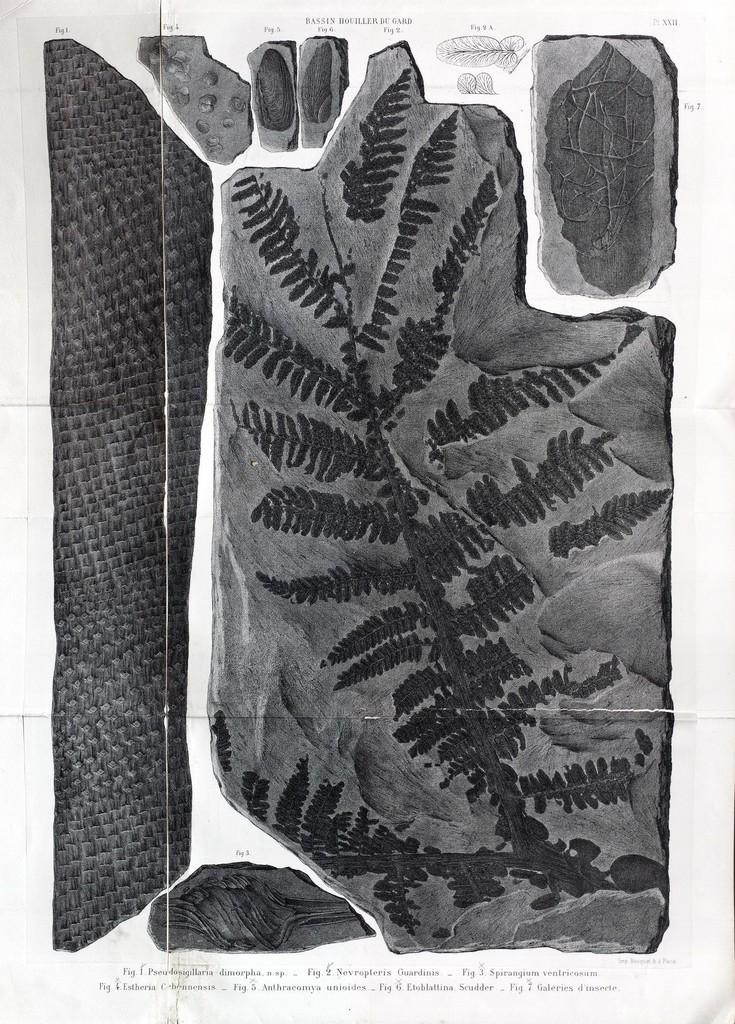What is the color scheme of the image? The image is black and white. What object is present in the image? There is a paper in the image. What can be found on the paper? The paper has images and text on it. Can you tell me how many buttons are attached to the pipe in the image? There is no pipe or button present in the image; it features a paper with images and text. 